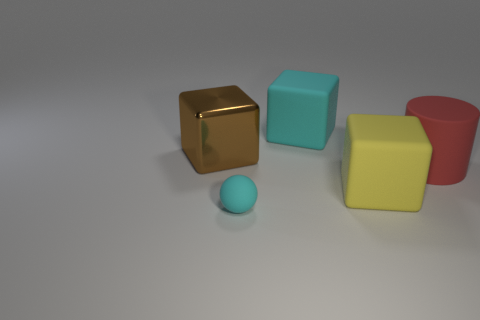Add 3 metal cubes. How many objects exist? 8 Subtract all balls. How many objects are left? 4 Subtract all large yellow rubber cubes. Subtract all rubber cubes. How many objects are left? 2 Add 5 cubes. How many cubes are left? 8 Add 5 big purple balls. How many big purple balls exist? 5 Subtract 0 cyan cylinders. How many objects are left? 5 